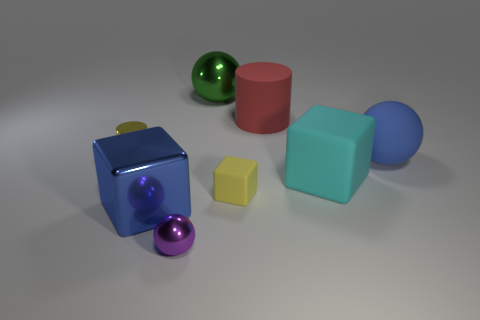The matte cube that is the same color as the tiny metal cylinder is what size?
Ensure brevity in your answer.  Small. Is there any other thing that is the same color as the shiny cylinder?
Ensure brevity in your answer.  Yes. There is a large cube that is in front of the cyan matte thing that is to the right of the cylinder that is behind the tiny yellow metallic thing; what is its material?
Provide a succinct answer. Metal. Is the color of the tiny cylinder the same as the tiny rubber block?
Ensure brevity in your answer.  Yes. How many objects are either small things or gray shiny blocks?
Offer a very short reply. 3. There is a matte thing that is in front of the blue rubber sphere and to the left of the cyan block; how big is it?
Provide a succinct answer. Small. How many large balls have the same material as the small block?
Offer a very short reply. 1. There is a cube that is made of the same material as the purple sphere; what color is it?
Your response must be concise. Blue. There is a large metal thing that is in front of the tiny shiny cylinder; is its color the same as the large rubber ball?
Offer a terse response. Yes. What is the material of the blue thing left of the purple sphere?
Provide a short and direct response. Metal. 